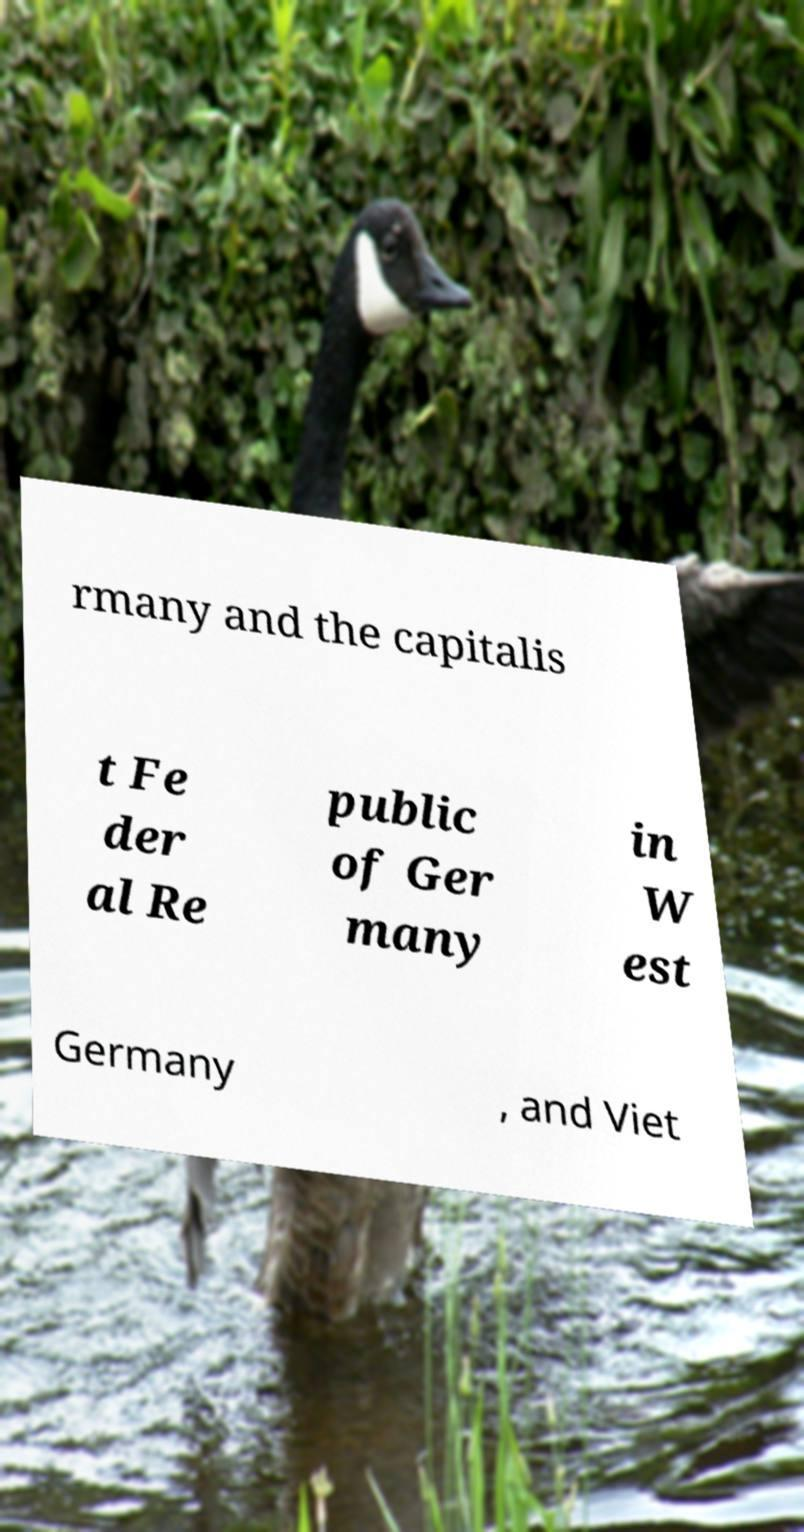Please read and relay the text visible in this image. What does it say? rmany and the capitalis t Fe der al Re public of Ger many in W est Germany , and Viet 